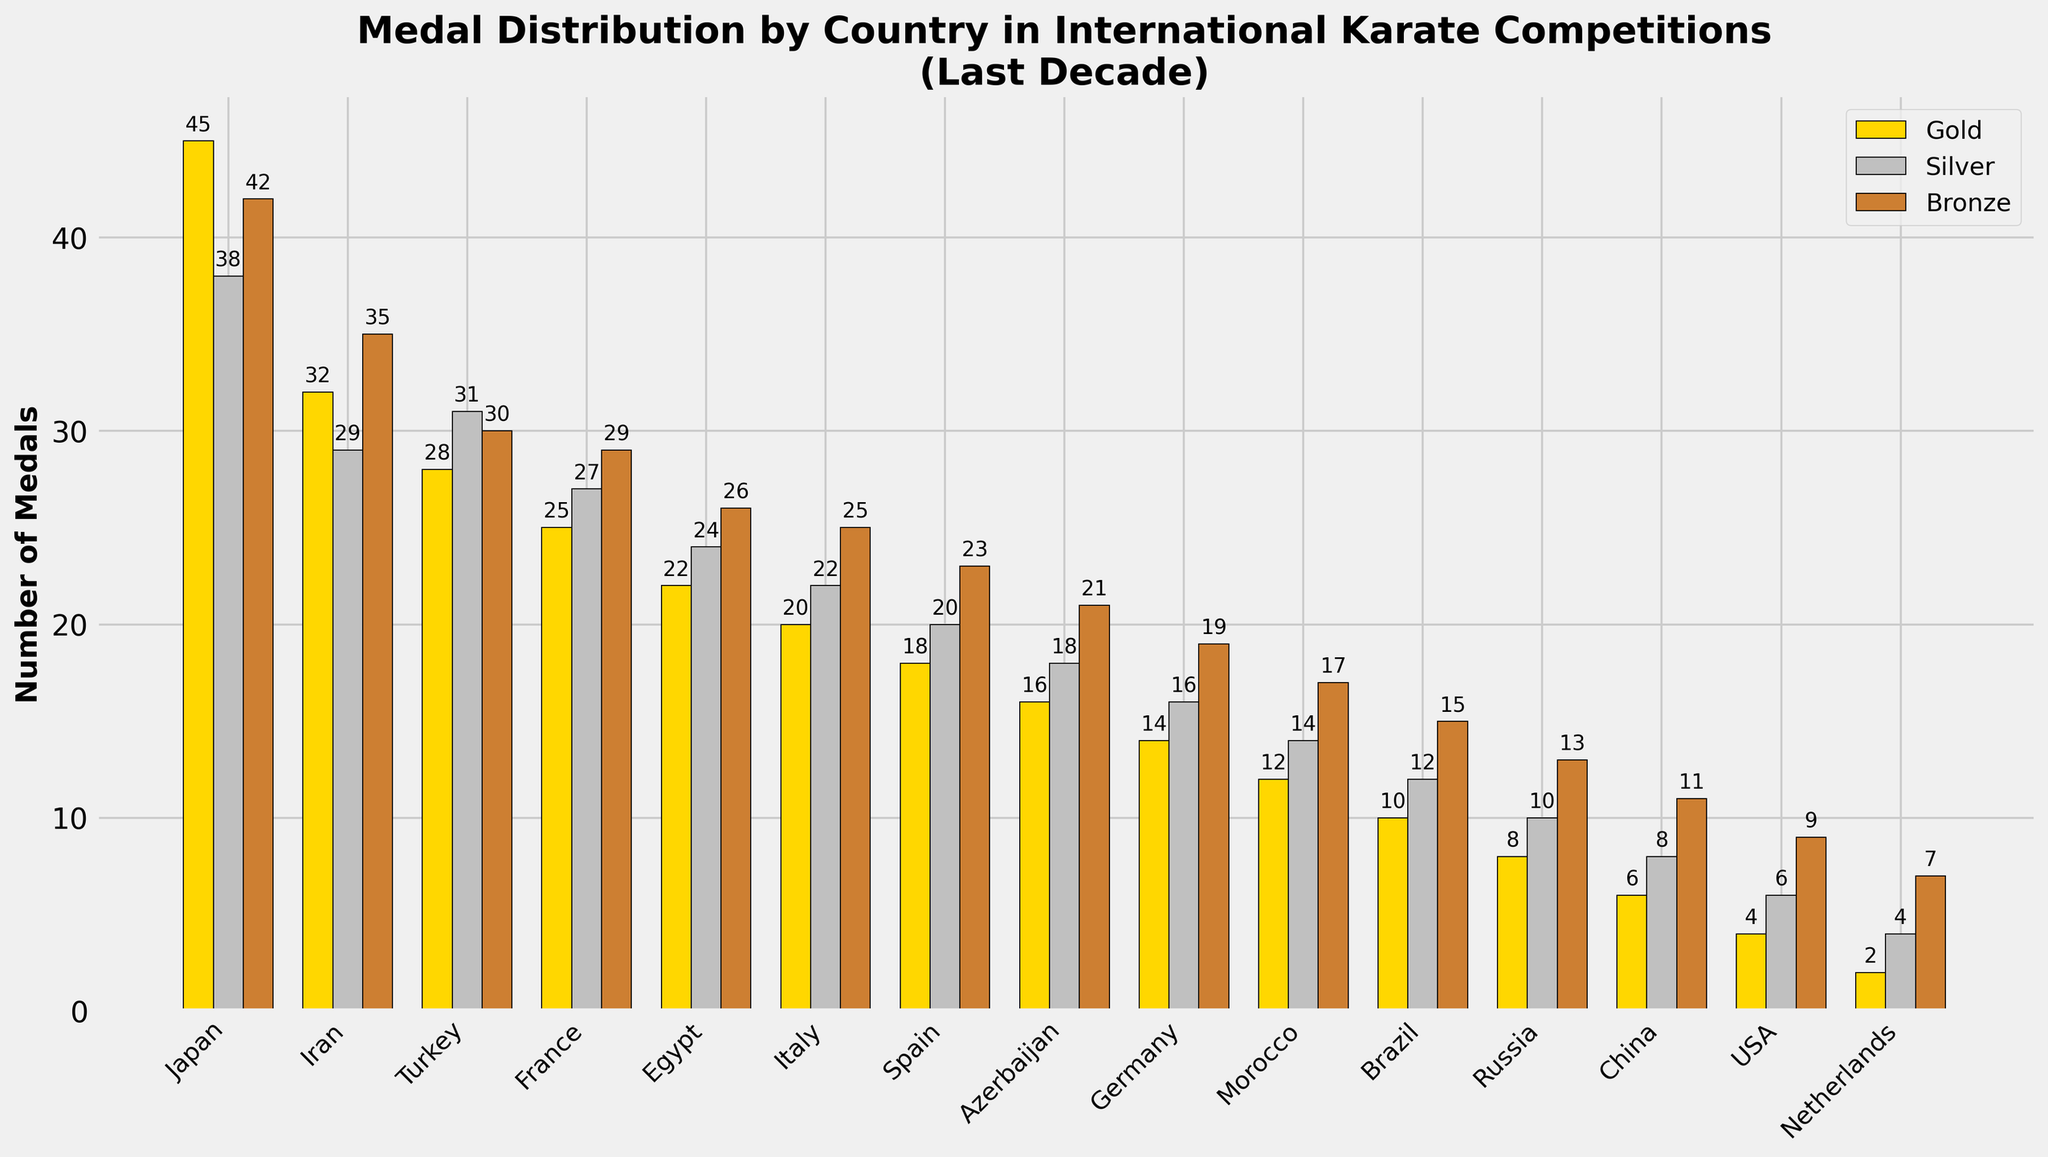Which country won the most gold medals? The height of the gold medal bar is tallest for Japan compared to other countries.
Answer: Japan What is the total number of bronze medals won by Egypt and Spain combined? The number of bronze medals for Egypt is 26 and for Spain is 23, so combined it is 26 + 23 = 49.
Answer: 49 Which country has a higher total medal count, France or Turkey? The total medal count for France is 81 and for Turkey is 89.
Answer: Turkey How many more silver medals did Iran win compared to Germany? Iran has 29 silver medals and Germany has 16 silver medals, so Iran won 29 - 16 = 13 more silver medals.
Answer: 13 What is the average number of gold medals won by Japan and Iran? The number of gold medals for Japan is 45 and for Iran is 32, so the average is (45 + 32) / 2 = 38.5.
Answer: 38.5 Which medal is the most frequent for Brazil, gold, silver, or bronze? The bar heights representing medals for Brazil show that bronze (15) is taller than gold (10) and silver (12).
Answer: Bronze How many more total medals has Italy won compared to Morocco? Italy's total is 67 medals and Morocco's total is 43; the difference is 67 - 43 = 24 medals.
Answer: 24 What is the approximate ratio of gold medals to total medals for the USA? The USA has 4 gold medals and 19 total medals, so the ratio is approximately 4 / 19.
Answer: 4/19 Which country has the lowest total medal count? The shortest total medals bar is for the Netherlands, with a count of 13.
Answer: Netherlands How many total bronze medals did the top 5 countries win combined? The bronze medals for Japan (42), Iran (35), Turkey (30), France (29), and Egypt (26), so the total is 42 + 35 + 30 + 29 + 26 = 162.
Answer: 162 